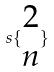Convert formula to latex. <formula><loc_0><loc_0><loc_500><loc_500>s \{ \begin{matrix} 2 \\ n \end{matrix} \}</formula> 